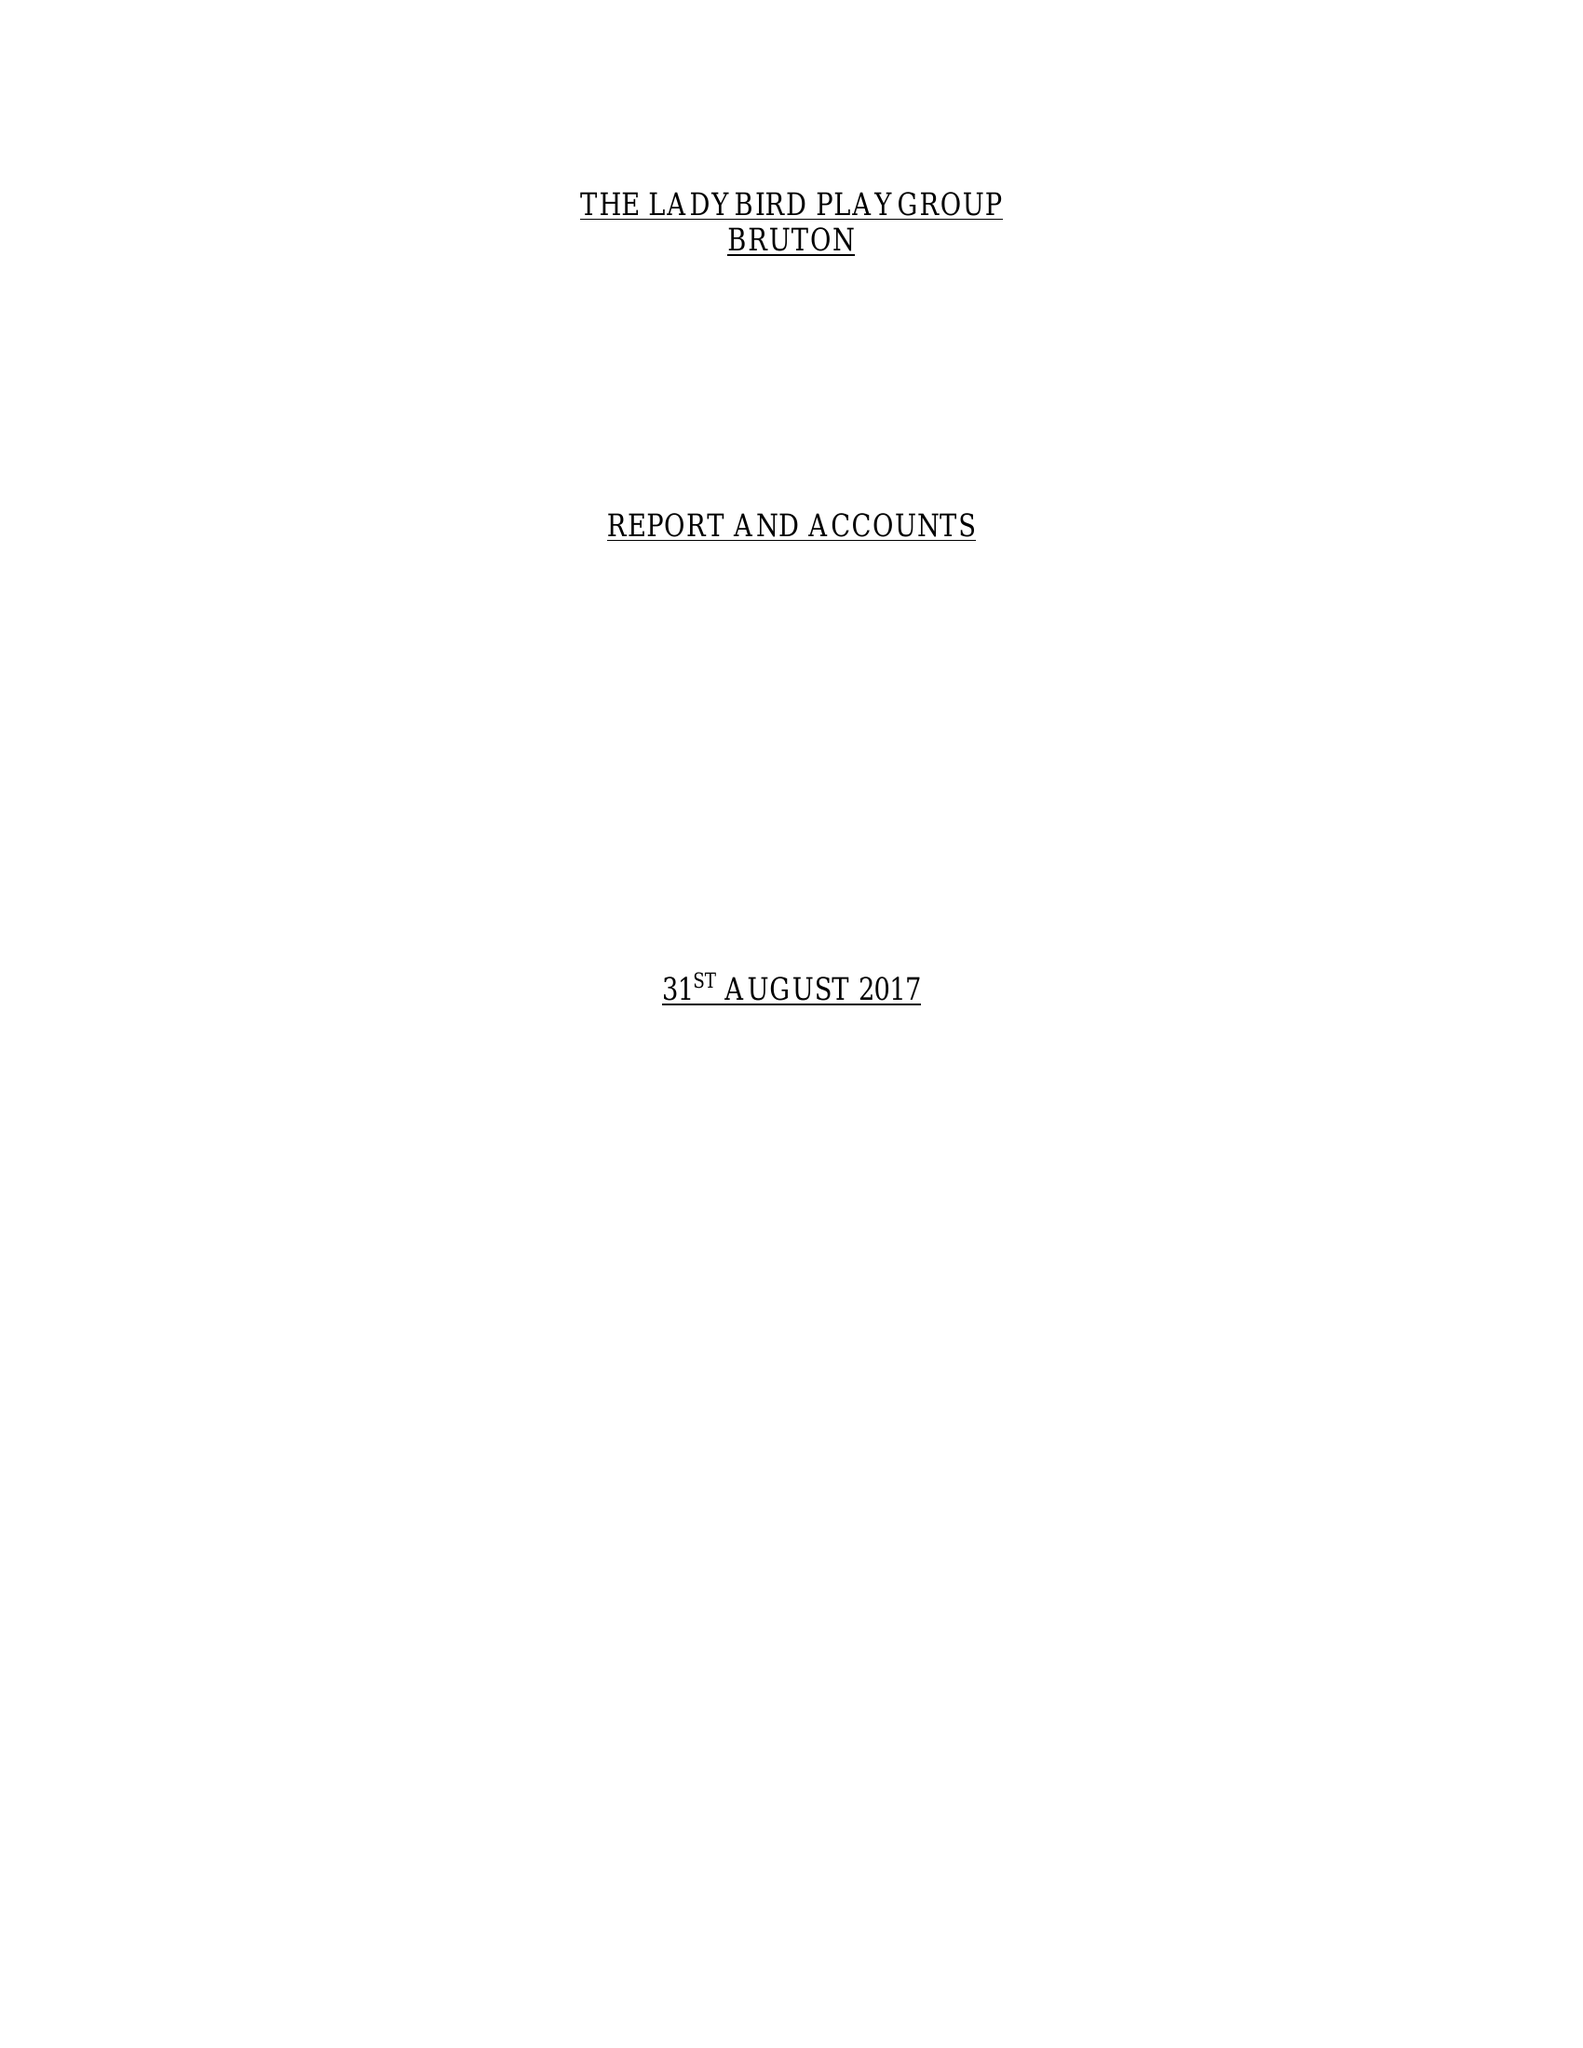What is the value for the address__street_line?
Answer the question using a single word or phrase. GODMINSTER LANE 